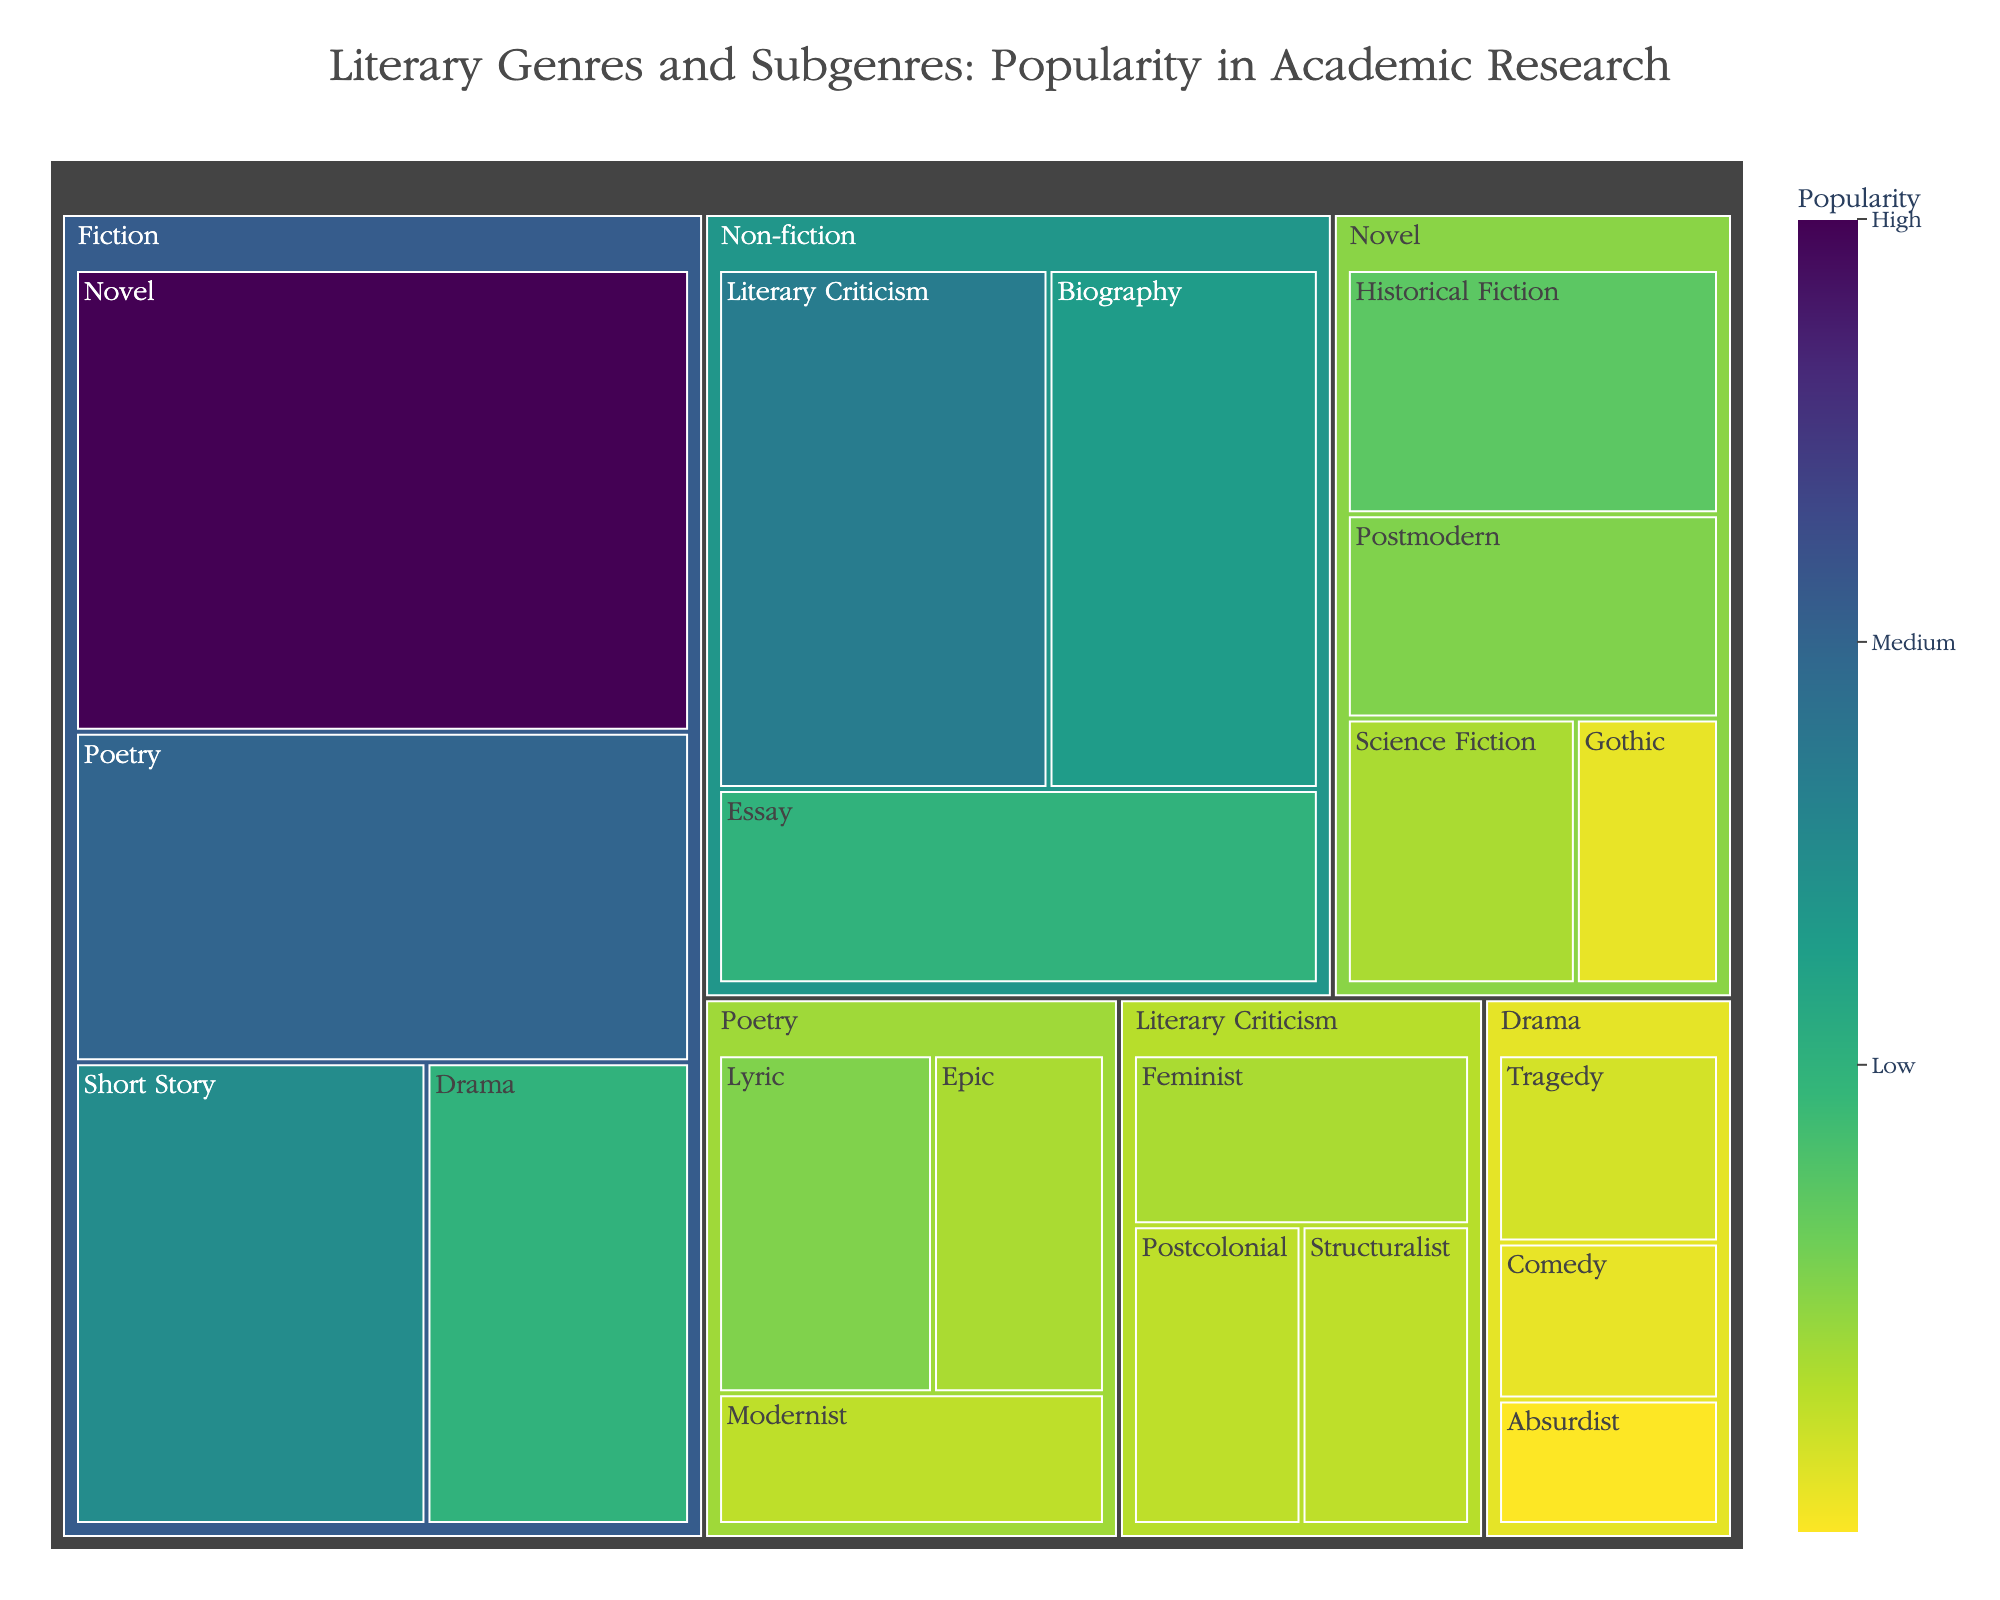What is the most popular genre in academic research according to the figure? The treemap visually displays the size of each genre's popularity, and Fiction covers the largest area. Therefore, Fiction is the most popular genre.
Answer: Fiction Under the Fiction genre, which subgenre has the highest popularity? By visually inspecting the section under Fiction in the treemap, Novel has the highest popularity value and the largest area compared to Short Story, Poetry, and Drama.
Answer: Novel How does the popularity of the Lyric subgenre compare to the Epic subgenre within Poetry? Looking at the Poetry section, the size and popularity value of Lyric (10) is larger than that of Epic (8).
Answer: Lyric is more popular than Epic What is the total popularity of the Drama subgenre within Fiction? Adding the popularity values of all Drama subgenres: Tragedy (6), Comedy (5), and Absurdist (4), we get 6 + 5 + 4 = 15.
Answer: 15 Which has greater popularity: Historical Fiction or Science Fiction subgenre under Novel? Comparing the popularity values, Historical Fiction (12) is greater than Science Fiction (8).
Answer: Historical Fiction How does the popularity of the Essay compare to the entire Non-fiction genre? Essay's popularity is 15. To find the total popularity of Non-fiction, add Biography (18), Literary Criticism (22), and Essay (15): 18 + 22 + 15 = 55. Essay (15) is a part of this total.
Answer: Essay has a lower popularity compared to the total Non-fiction genre What is the combined popularity of Feminist and Postcolonial subgenres within Literary Criticism? Adding the popularity values of Feminist (8) and Postcolonial (7), the combined popularity is 8 + 7 = 15.
Answer: 15 Which subgenre has the least popularity across the entire figure? By examining all sections, the Gothic subgenre under Novel has the smallest value, which is 5.
Answer: Gothic What's the average popularity of subgenres under the Novel category? Adding the popularity values of Novel's subgenres: Historical Fiction (12), Science Fiction (8), Postmodern (10), Gothic (5), and dividing by the number of subgenres (4): (12 + 8 + 10 + 5) / 4 = 8.75.
Answer: 8.75 What is the color scale applied to the treemap representing? By referring to the color legend provided, the color scale from low to high popularity is applied to visually indicate the differences in popularity values among genres and subgenres.
Answer: It represents popularity levels from low to high 